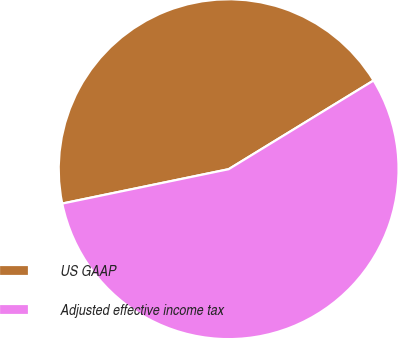Convert chart to OTSL. <chart><loc_0><loc_0><loc_500><loc_500><pie_chart><fcel>US GAAP<fcel>Adjusted effective income tax<nl><fcel>44.5%<fcel>55.5%<nl></chart> 